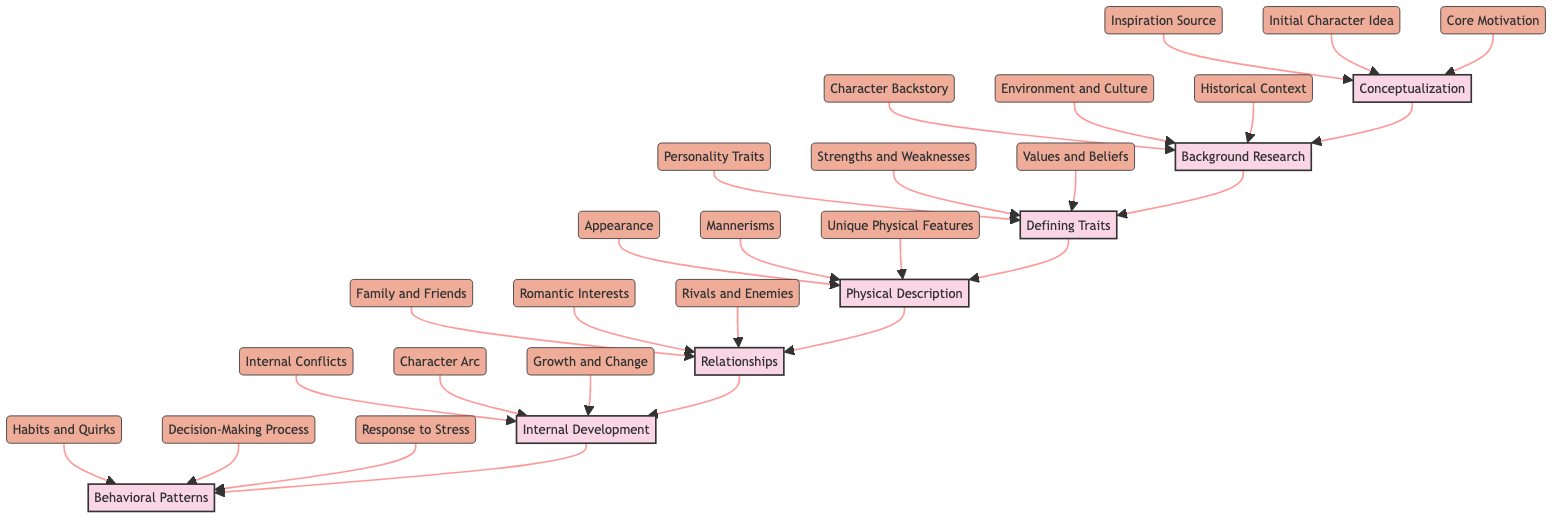What is the first stage in the diagram? The first stage listed in the flowchart is Conceptualization. This can be found at the bottom of the flowchart, indicating the beginning of the character development process.
Answer: Conceptualization How many components are in the Defining Traits stage? The Defining Traits stage has three components: Personality Traits, Strengths and Weaknesses, and Values and Beliefs. This can be counted directly from the components listed under that stage.
Answer: 3 What are the main components of the Background Research stage? The components listed for the Background Research stage are Character Backstory, Environment and Culture, and Historical Context. These can be found under the corresponding stage in the diagram.
Answer: Character Backstory, Environment and Culture, Historical Context Which stage comes after Physical Description? After Physical Description, the next stage is Relationships, as indicated by the flow of the diagram moving upwards from Physical Description to Relationships.
Answer: Relationships What is the last stage in this character development process? The last stage in the diagram is Behavioral Patterns, which is found at the top of the flowchart as the final development step.
Answer: Behavioral Patterns What components contribute to the Internal Development stage? The Internal Development stage is made up of Internal Conflicts, Character Arc, and Growth and Change. This information is directly extracted from the components listed under that stage.
Answer: Internal Conflicts, Character Arc, Growth and Change How many stages are there in total in the flowchart? There are seven stages in total in the flowchart, which can be counted from the distinct stages listed from bottom to top in the diagram.
Answer: 7 What is the relationship between Conceptualization and Behavioral Patterns? Conceptualization is the first stage, and it leads to Behavioral Patterns as the final stage, illustrating the sequential flow of character development through the diagram.
Answer: Sequential flow What is a key focus of the Defining Traits stage? The Defining Traits stage focuses on developing a character's Personality Traits, Strengths and Weaknesses, and Values and Beliefs, all essential for creating a complex character.
Answer: Personality Traits, Strengths and Weaknesses, Values and Beliefs What is the core motivation in the Conceptualization stage? The term "Core Motivation" is one of the components outlined in the Conceptualization stage, which reflects what drives the character’s actions throughout the story.
Answer: Core Motivation 